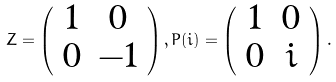Convert formula to latex. <formula><loc_0><loc_0><loc_500><loc_500>Z = \left ( \begin{array} { c c } 1 & 0 \\ 0 & - 1 \end{array} \right ) , P ( i ) = \left ( \begin{array} { c c } 1 & 0 \\ 0 & i \end{array} \right ) .</formula> 